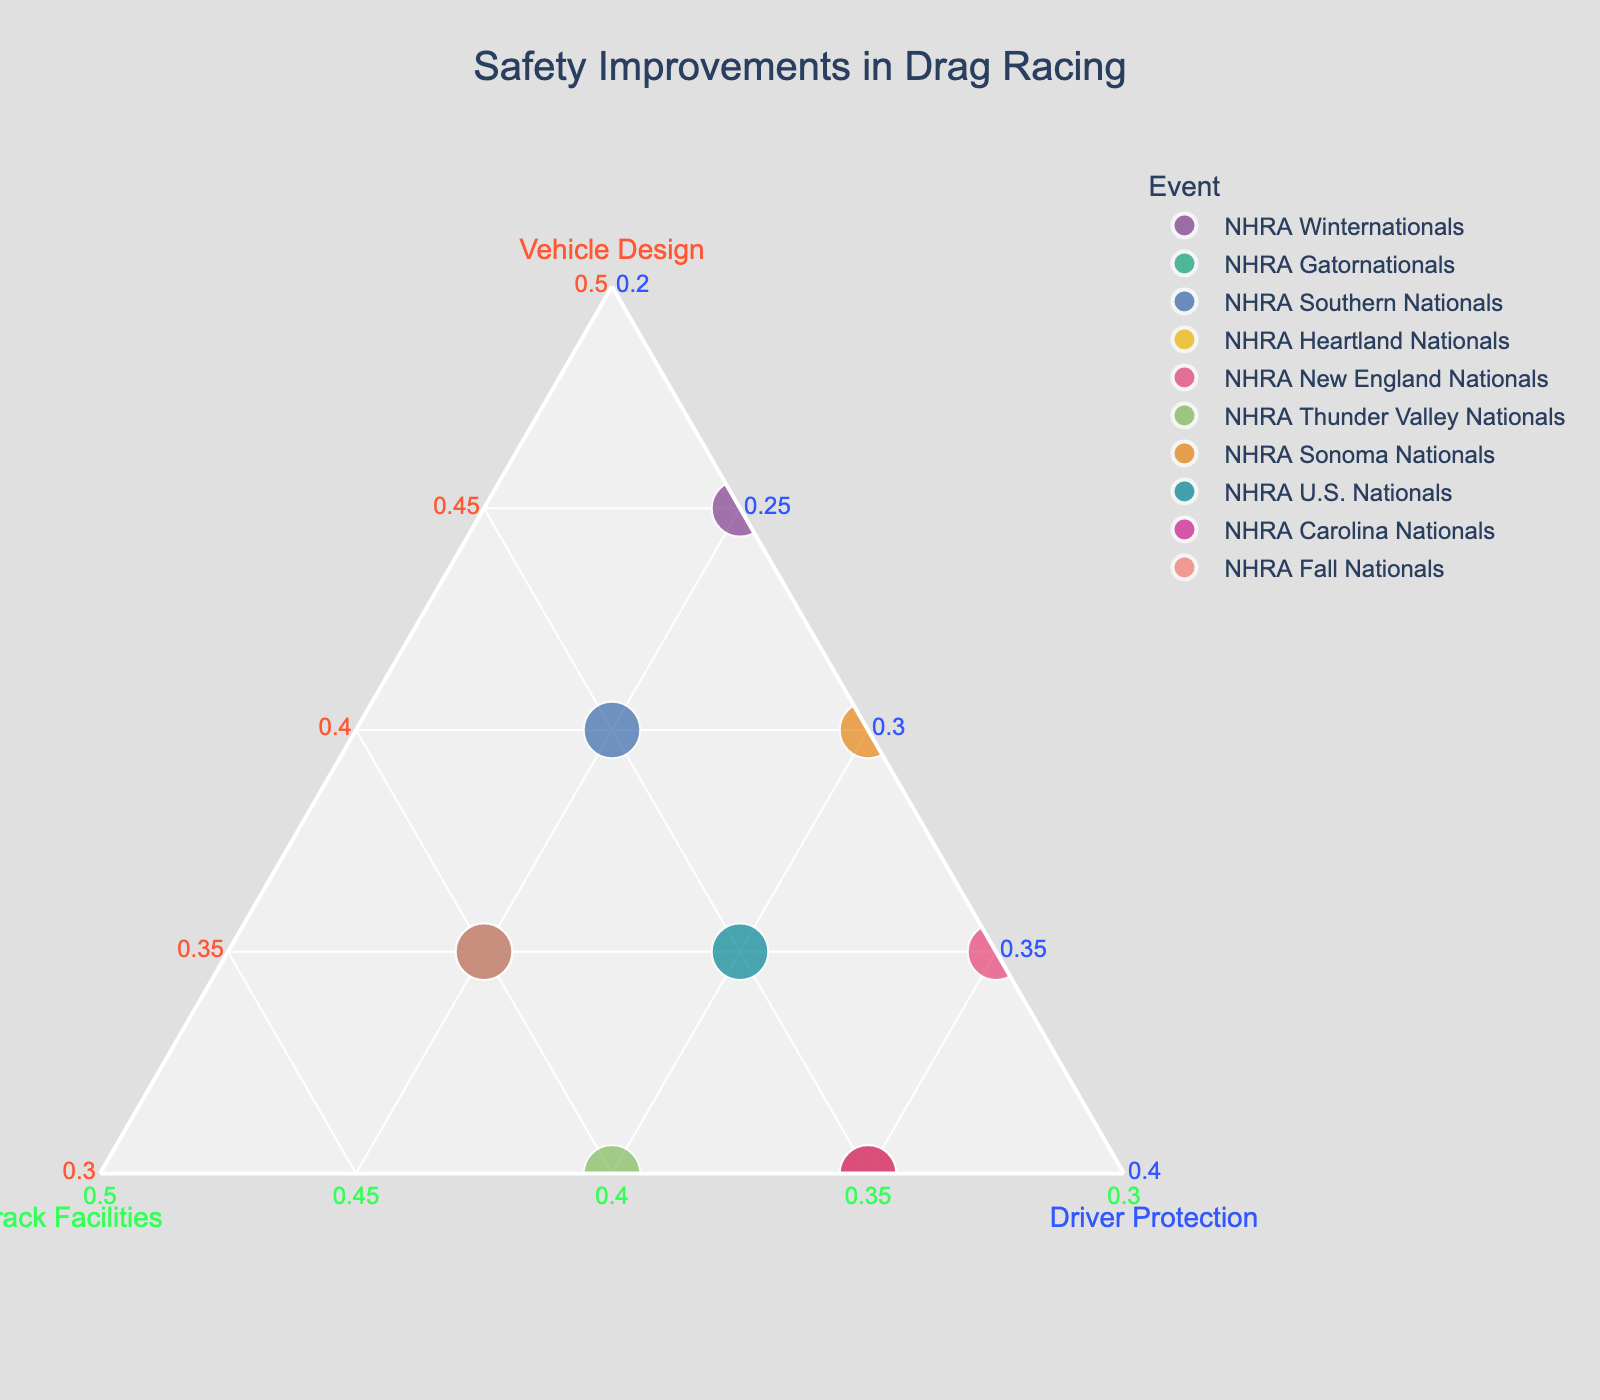What's the title of the ternary plot? The title is shown prominently at the top of the plot, which is designed to convey the overall subject of the data being visualized.
Answer: Safety Improvements in Drag Racing How many events are represented in the plot? Each data point in the ternary plot corresponds to an event, and the figure should contain a total count. By counting the individual points, one can determine the number of events.
Answer: 10 Which event prioritizes vehicle design the most? Referring to the axis labeled "Vehicle Design," the event with the highest percentage on this axis is the one that prioritizes vehicle design the most.
Answer: NHRA Winternationals Which two events have the same focus on driver protection? By comparing points along the "Driver Protection" axis, you can identify which events have the same percentage value on this axis.
Answer: NHRA Heartland Nationals and NHRA Carolina Nationals What is the combined focus on track facilities and driver protection for NHRA New England Nationals? To find the combined focus, add the percentages of Track Facilities and Driver Protection for the NHRA New England Nationals event.
Answer: 65% Which event has the highest focus on track facilities? Look for the point that ranks the highest on the "Track Facilities" axis. This will be the event with the highest percentage in that area.
Answer: NHRA Thunder Valley Nationals Do any events have an equal focus on vehicle design and driver protection? Examine the points and compare values where the percentages for vehicle design and driver protection are the same.
Answer: NHRA New England Nationals Which event has the lowest focus on track facilities? Find the point with the smallest percentage value on the "Track Facilities" axis.
Answer: NHRA Winternationals How many events have a higher focus on driver protection compared to vehicle design? Count the number of points where the percentage for driver protection is greater than the percentage for vehicle design by comparing values visually.
Answer: 3 Which events have the same combination of vehicle design and driver protection? Identify any events that have matching percentages for both vehicle design and driver protection by looking at the points on the plot.
Answer: NHRA Fall Nationals and NHRA Gatornationals 